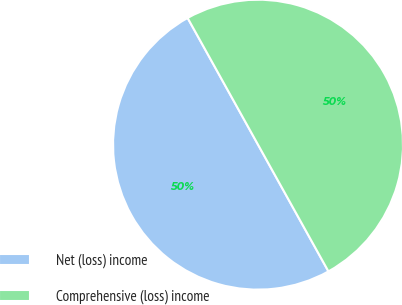Convert chart. <chart><loc_0><loc_0><loc_500><loc_500><pie_chart><fcel>Net (loss) income<fcel>Comprehensive (loss) income<nl><fcel>50.0%<fcel>50.0%<nl></chart> 